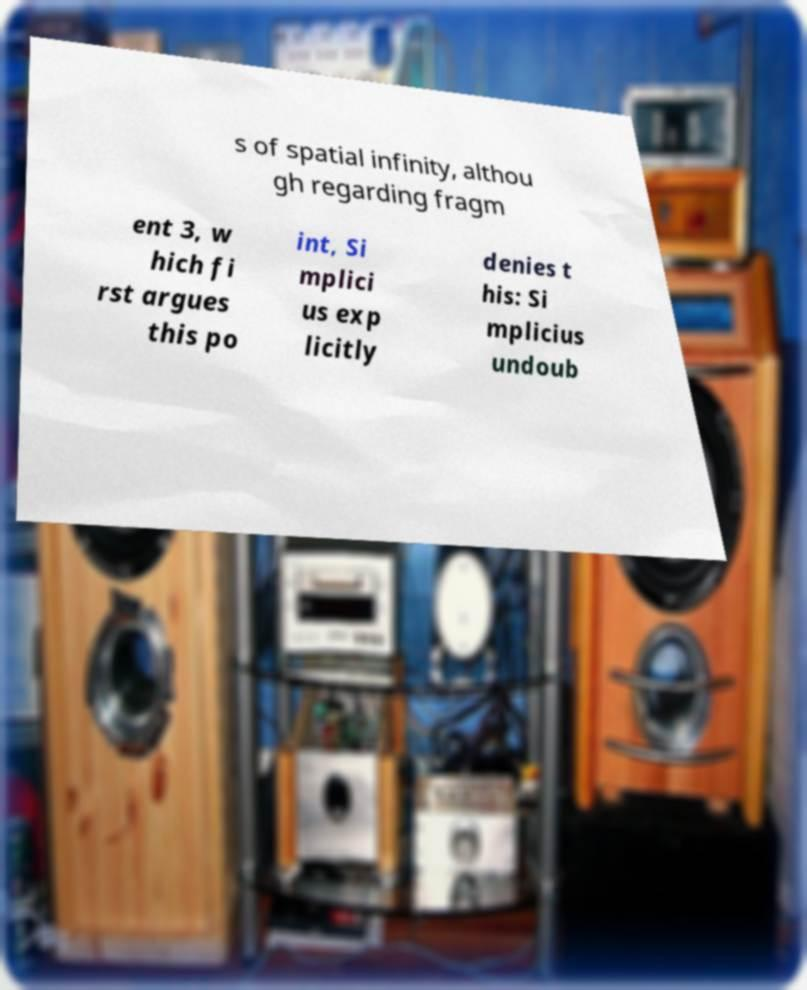I need the written content from this picture converted into text. Can you do that? s of spatial infinity, althou gh regarding fragm ent 3, w hich fi rst argues this po int, Si mplici us exp licitly denies t his: Si mplicius undoub 